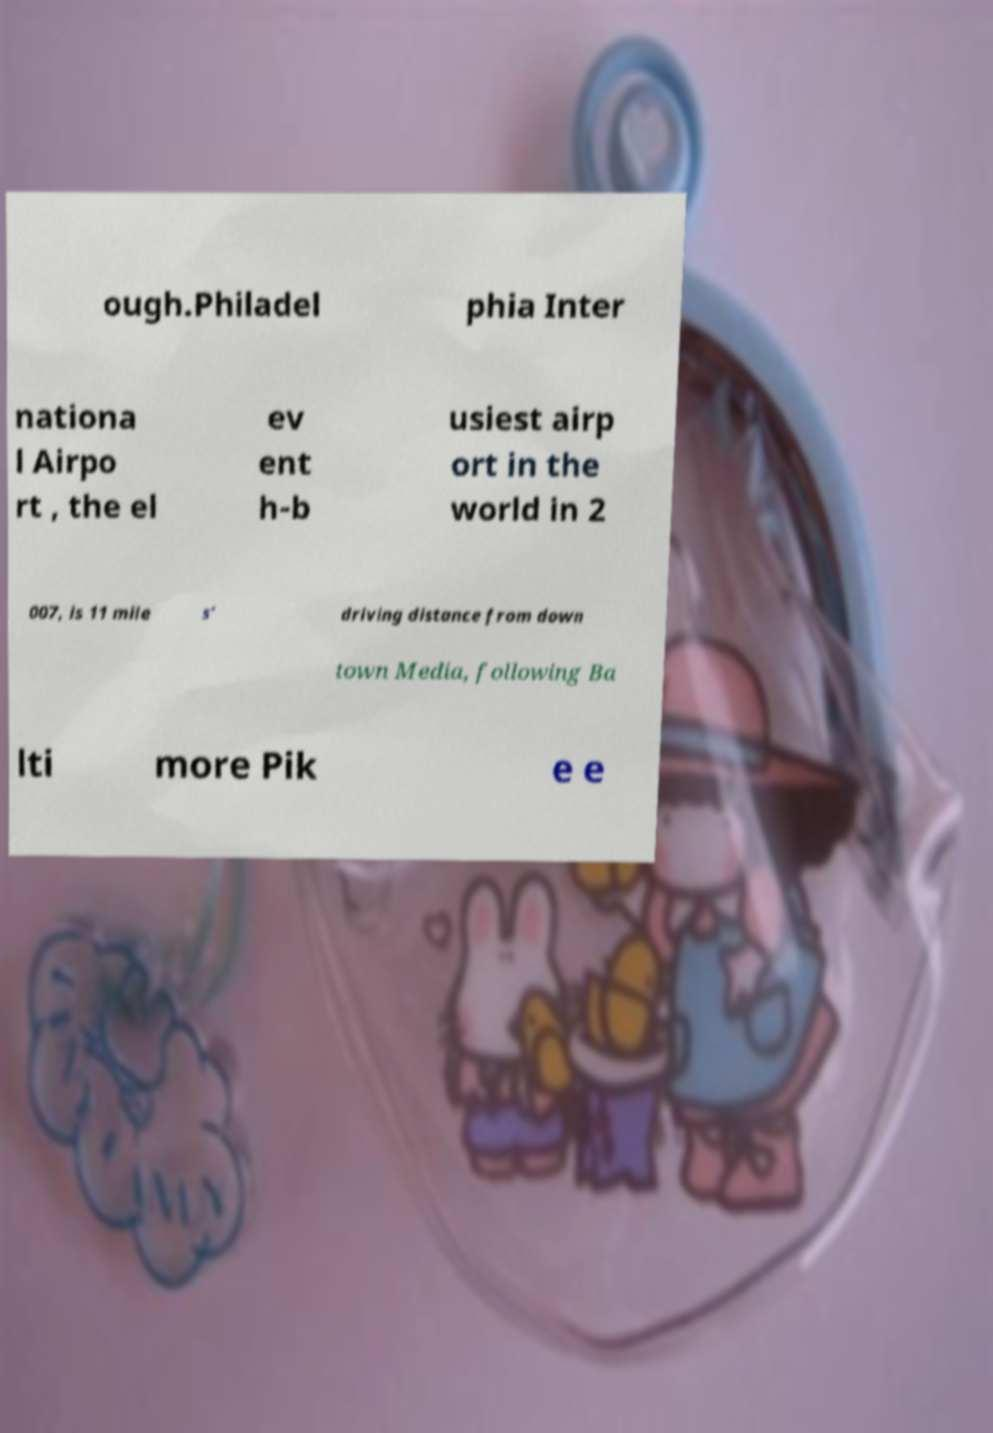Could you extract and type out the text from this image? ough.Philadel phia Inter nationa l Airpo rt , the el ev ent h-b usiest airp ort in the world in 2 007, is 11 mile s' driving distance from down town Media, following Ba lti more Pik e e 